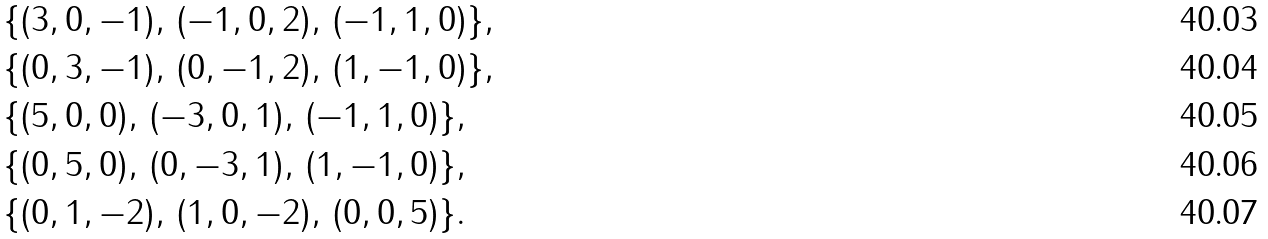<formula> <loc_0><loc_0><loc_500><loc_500>& \{ ( 3 , 0 , - 1 ) , \, ( - 1 , 0 , 2 ) , \, ( - 1 , 1 , 0 ) \} , \\ & \{ ( 0 , 3 , - 1 ) , \, ( 0 , - 1 , 2 ) , \, ( 1 , - 1 , 0 ) \} , \\ & \{ ( 5 , 0 , 0 ) , \, ( - 3 , 0 , 1 ) , \, ( - 1 , 1 , 0 ) \} , \\ & \{ ( 0 , 5 , 0 ) , \, ( 0 , - 3 , 1 ) , \, ( 1 , - 1 , 0 ) \} , \\ & \{ ( 0 , 1 , - 2 ) , \, ( 1 , 0 , - 2 ) , \, ( 0 , 0 , 5 ) \} .</formula> 